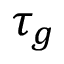<formula> <loc_0><loc_0><loc_500><loc_500>\tau _ { g }</formula> 